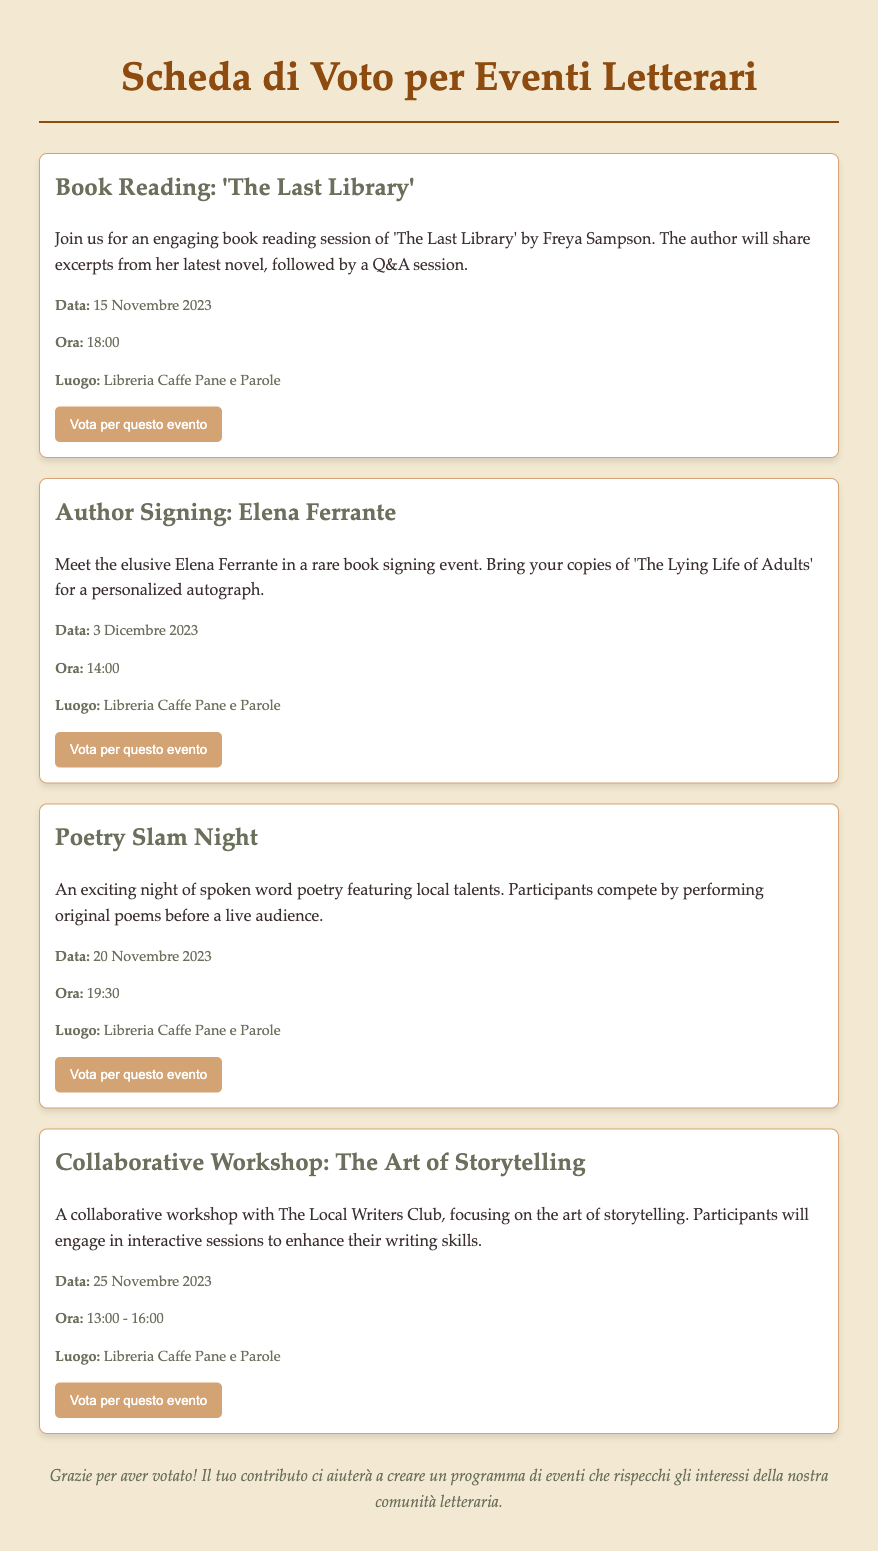Qual è il titolo del libro letto durante l'evento? Il titolo del libro è specificato nell'evento di lettura.
Answer: 'The Last Library' Quando si tiene l'evento di firma dell'autore? La data dell'evento di firma è indicata nelle informazioni dell'evento.
Answer: 3 Dicembre 2023 Qual è l'orario di inizio della Poetry Slam Night? L'orario di inizio è fornito nei dettagli dell'evento di poesia.
Answer: 19:30 Chi è l'autore presente all'evento di firma? Il nome dell'autore è menzionato nel titolo dell'evento di firma.
Answer: Elena Ferrante Qual è l'ultima data degli eventi elencati? La data finale degli eventi è nel dettaglio dell'ultimo evento.
Answer: 25 Novembre 2023 Quale attività è offerta durante il workshop? L'argomento del workshop è descritto nel testo dell'evento.
Answer: The Art of Storytelling Quanti eventi si stanno svolgendo alla Libreria Caffe Pane e Parole? Il numero di eventi è dedotto contando gli eventi elencati.
Answer: 4 Qual è l'obiettivo della scheda di voto? L'obiettivo è spiegato nel messaggio di chiusura del documento.
Answer: Creare un programma di eventi che rispecchi gli interessi della comunità letteraria Quale colore caratterizza il pulsante di voto? Il colore del pulsante di voto è menzionato nelle informazioni di stile del documento.
Answer: D4A373 